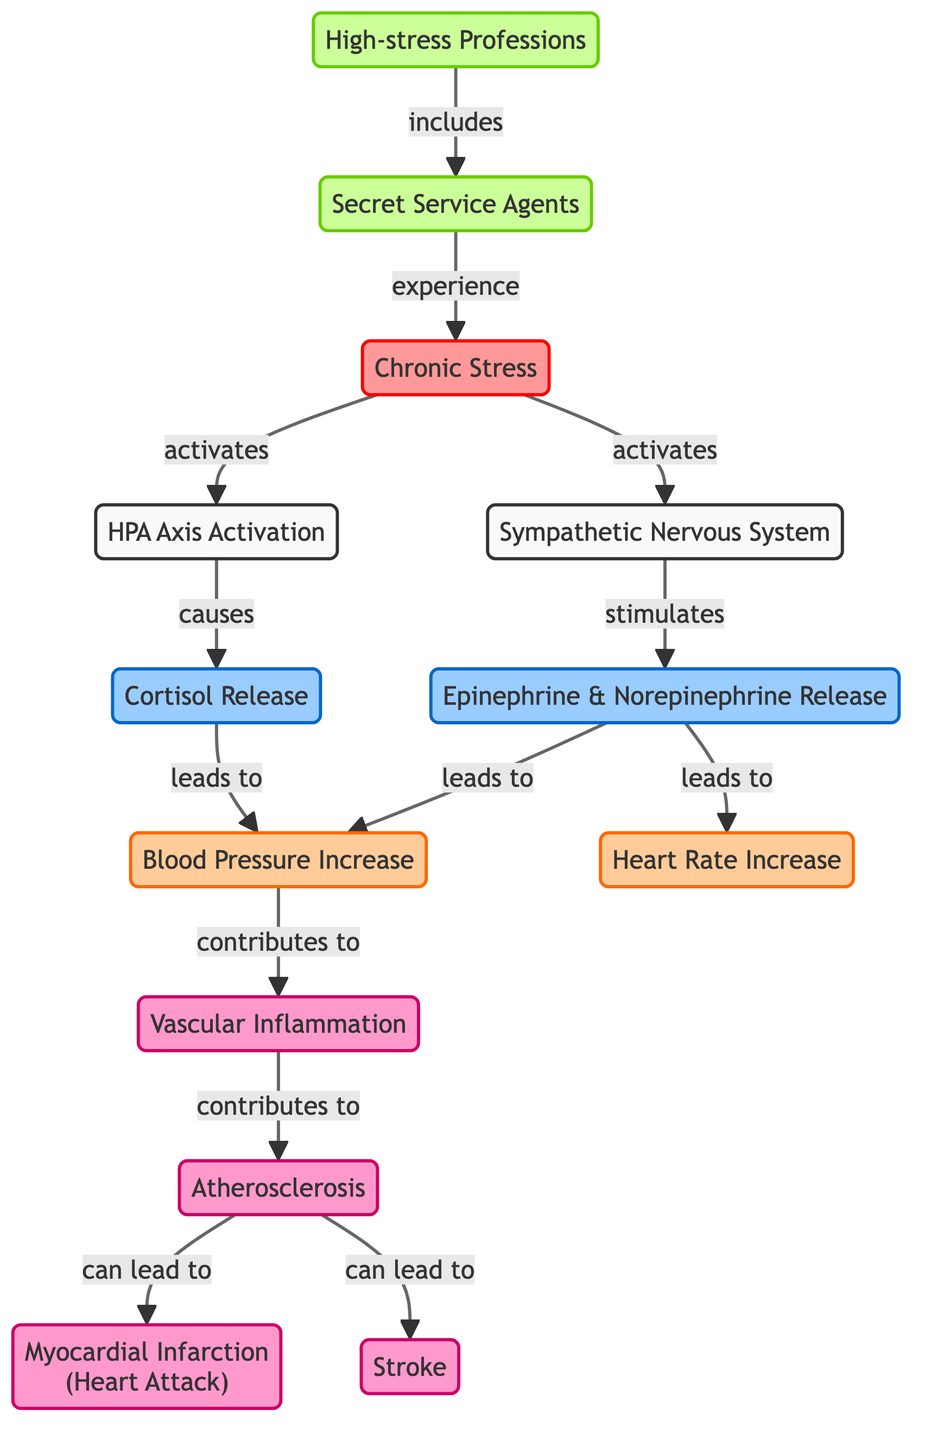What is the primary source of chronic stress in this context? The diagram indicates that "Secret Service Agents" experience "Chronic Stress." This is explicitly noted in the flowchart where one of the nodes directly links secret service agents to chronic stress, identifying them as the source.
Answer: Chronic Stress How many hormones are released as a result of the stress pathways? The diagram shows two hormones released: "Cortisol" and "Epinephrine & Norepinephrine." Both are depicted in the flowchart and lead to various physiological responses. Counting these nodes gives the total number of hormones.
Answer: 2 What condition can result directly from vascular inflammation? According to the diagram, "Atherosclerosis" is listed as a condition that results from "Vascular Inflammation." The link between these two elements is clearly indicated in the flowchart.
Answer: Atherosclerosis Which profession is shown to have a high level of chronic stress? The diagram specifies that "High-stress Professions" include "Secret Service Agents." This classification directly identifies the profession associated with chronic stress.
Answer: Secret Service Agents What are the symptoms associated with stress-induced hormone release? The flowchart identifies two symptoms: "Blood Pressure Increase" and "Heart Rate Increase," both of which are linked to the hormonal response triggered by stress pathways. These symptoms follow the release of hormones in the diagram.
Answer: Blood Pressure Increase, Heart Rate Increase What leads to myocardial infarction as per the diagram? Following the flow of the diagram, "Atherosclerosis" leads to "Myocardial Infarction." This is crucial since it illustrates how preceding conditions from stress pathways culminate in a heart attack.
Answer: Atherosclerosis What is the impact of the "Sympathetic Nervous System" as depicted? The "Sympathetic Nervous System" activates the release of "Epinephrine & Norepinephrine," leading to increased heart rate and blood pressure. This indicates its significant role in the stress response and its immediate impact on the cardiovascular system.
Answer: Increases heart rate and blood pressure How does chronic stress affect vascular health in Secret Service agents? The diagram outlines that "Chronic Stress" activates physiological pathways resulting in "Vascular Inflammation," which can lead to "Atherosclerosis." This articulates the pathway from stress to vascular health impacts specifically in Secret Service agents.
Answer: Vascular Inflammation leading to Atherosclerosis 